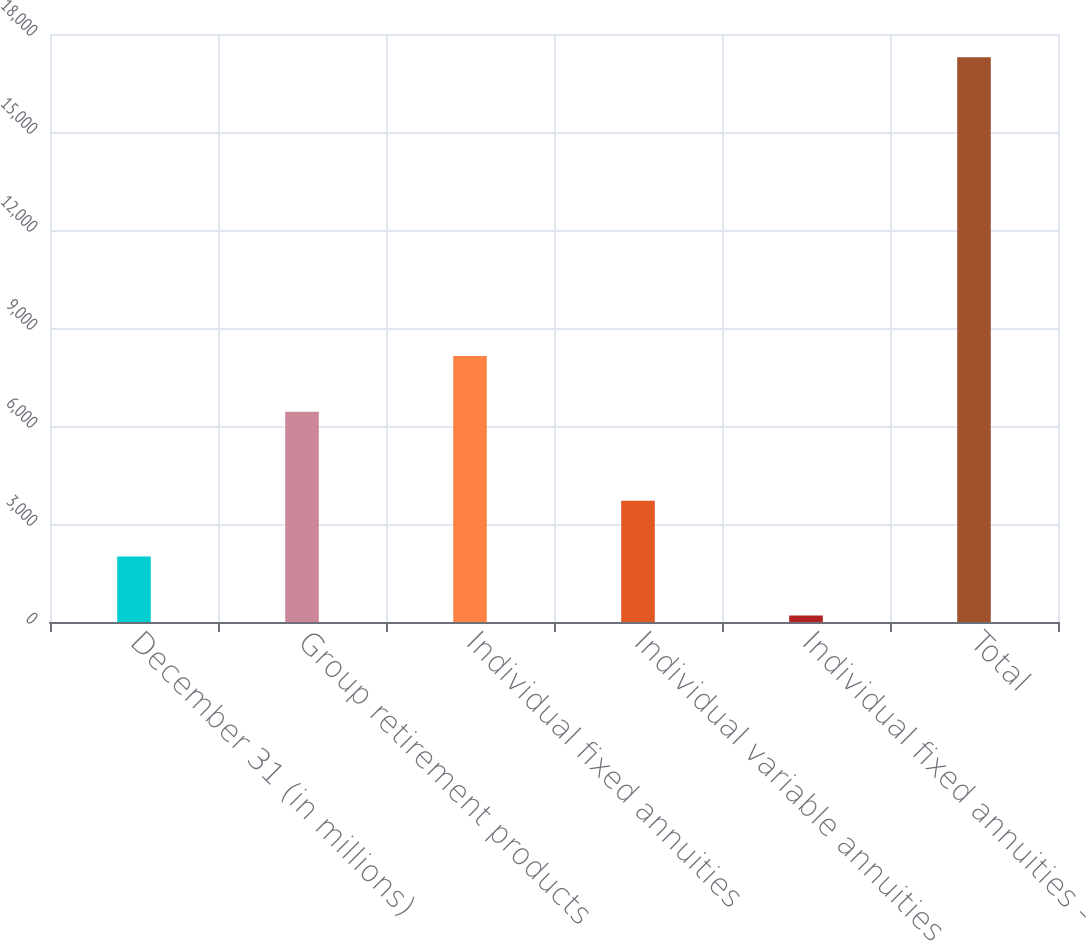<chart> <loc_0><loc_0><loc_500><loc_500><bar_chart><fcel>December 31 (in millions)<fcel>Group retirement products<fcel>Individual fixed annuities<fcel>Individual variable annuities<fcel>Individual fixed annuities -<fcel>Total<nl><fcel>2005<fcel>6436<fcel>8145.2<fcel>3714.2<fcel>200<fcel>17292<nl></chart> 